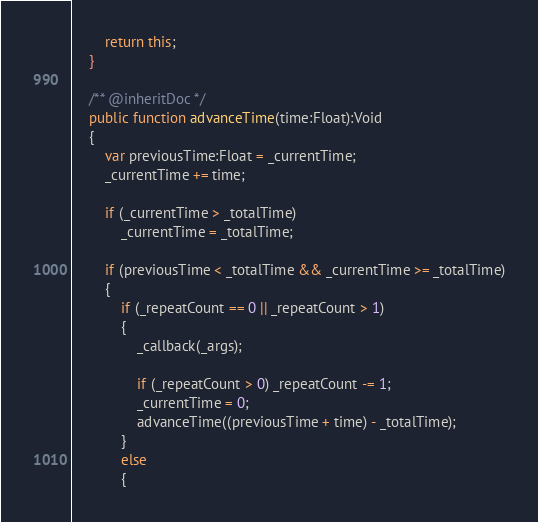<code> <loc_0><loc_0><loc_500><loc_500><_Haxe_>        return this;
    }
    
    /** @inheritDoc */
    public function advanceTime(time:Float):Void
    {
        var previousTime:Float = _currentTime;
        _currentTime += time;

        if (_currentTime > _totalTime)
            _currentTime = _totalTime;
        
        if (previousTime < _totalTime && _currentTime >= _totalTime)
        {                
            if (_repeatCount == 0 || _repeatCount > 1)
            {
                _callback(_args);
                
                if (_repeatCount > 0) _repeatCount -= 1;
                _currentTime = 0;
                advanceTime((previousTime + time) - _totalTime);
            }
            else
            {</code> 